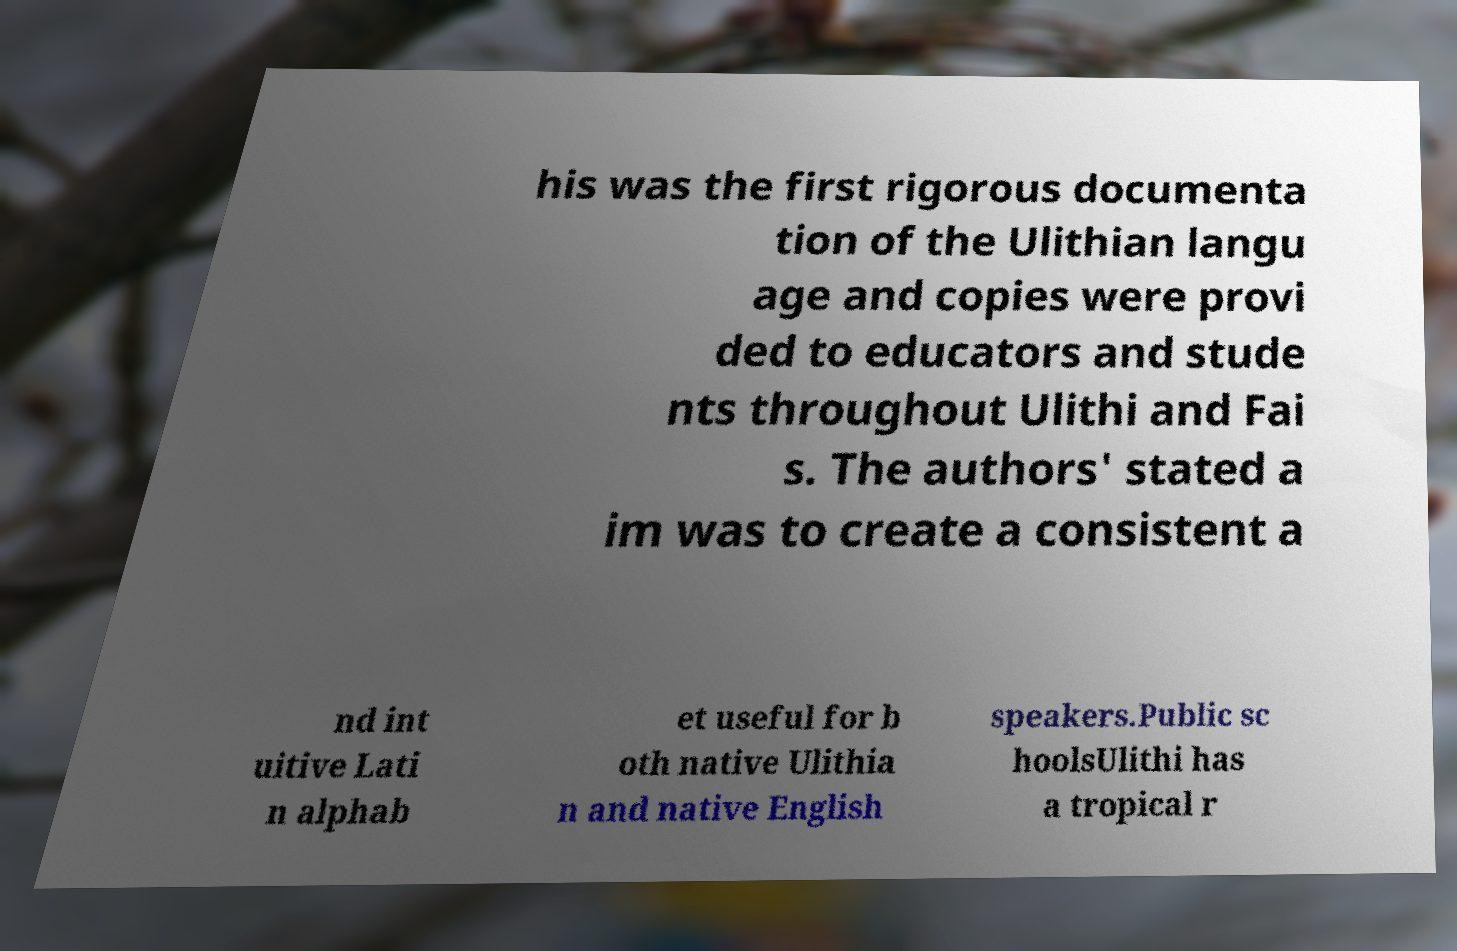Can you read and provide the text displayed in the image?This photo seems to have some interesting text. Can you extract and type it out for me? his was the first rigorous documenta tion of the Ulithian langu age and copies were provi ded to educators and stude nts throughout Ulithi and Fai s. The authors' stated a im was to create a consistent a nd int uitive Lati n alphab et useful for b oth native Ulithia n and native English speakers.Public sc hoolsUlithi has a tropical r 